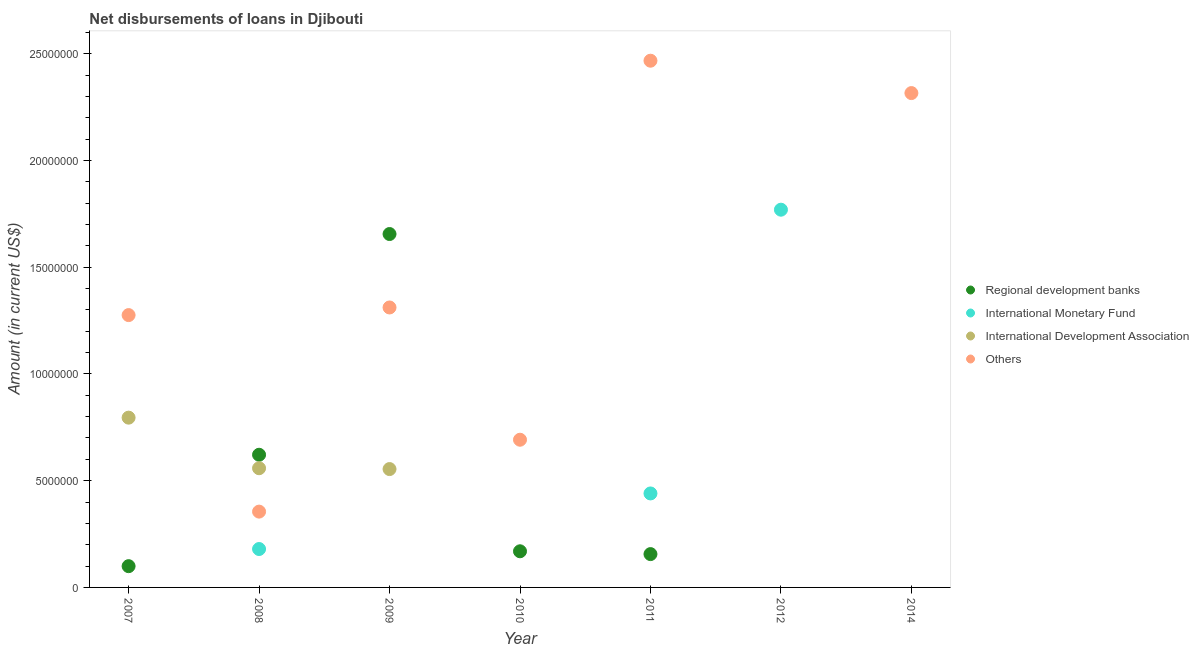How many different coloured dotlines are there?
Offer a very short reply. 4. Across all years, what is the maximum amount of loan disimbursed by other organisations?
Your response must be concise. 2.47e+07. In which year was the amount of loan disimbursed by international monetary fund maximum?
Make the answer very short. 2012. What is the total amount of loan disimbursed by international development association in the graph?
Ensure brevity in your answer.  1.91e+07. What is the difference between the amount of loan disimbursed by other organisations in 2007 and that in 2008?
Offer a very short reply. 9.20e+06. What is the difference between the amount of loan disimbursed by international development association in 2010 and the amount of loan disimbursed by regional development banks in 2012?
Provide a short and direct response. 0. What is the average amount of loan disimbursed by international development association per year?
Provide a short and direct response. 2.73e+06. In the year 2008, what is the difference between the amount of loan disimbursed by regional development banks and amount of loan disimbursed by other organisations?
Provide a succinct answer. 2.66e+06. What is the ratio of the amount of loan disimbursed by international development association in 2007 to that in 2009?
Your response must be concise. 1.43. What is the difference between the highest and the second highest amount of loan disimbursed by international monetary fund?
Offer a very short reply. 1.33e+07. What is the difference between the highest and the lowest amount of loan disimbursed by regional development banks?
Provide a short and direct response. 1.66e+07. In how many years, is the amount of loan disimbursed by international monetary fund greater than the average amount of loan disimbursed by international monetary fund taken over all years?
Ensure brevity in your answer.  2. Is the sum of the amount of loan disimbursed by regional development banks in 2008 and 2011 greater than the maximum amount of loan disimbursed by international development association across all years?
Offer a terse response. No. Is it the case that in every year, the sum of the amount of loan disimbursed by international monetary fund and amount of loan disimbursed by other organisations is greater than the sum of amount of loan disimbursed by international development association and amount of loan disimbursed by regional development banks?
Give a very brief answer. No. Is it the case that in every year, the sum of the amount of loan disimbursed by regional development banks and amount of loan disimbursed by international monetary fund is greater than the amount of loan disimbursed by international development association?
Your answer should be very brief. No. How many years are there in the graph?
Make the answer very short. 7. What is the difference between two consecutive major ticks on the Y-axis?
Provide a short and direct response. 5.00e+06. Are the values on the major ticks of Y-axis written in scientific E-notation?
Make the answer very short. No. Does the graph contain any zero values?
Your response must be concise. Yes. How are the legend labels stacked?
Give a very brief answer. Vertical. What is the title of the graph?
Ensure brevity in your answer.  Net disbursements of loans in Djibouti. Does "Energy" appear as one of the legend labels in the graph?
Provide a succinct answer. No. What is the Amount (in current US$) of Regional development banks in 2007?
Keep it short and to the point. 9.96e+05. What is the Amount (in current US$) in International Development Association in 2007?
Provide a succinct answer. 7.95e+06. What is the Amount (in current US$) of Others in 2007?
Provide a succinct answer. 1.28e+07. What is the Amount (in current US$) in Regional development banks in 2008?
Offer a terse response. 6.21e+06. What is the Amount (in current US$) in International Monetary Fund in 2008?
Provide a succinct answer. 1.80e+06. What is the Amount (in current US$) in International Development Association in 2008?
Give a very brief answer. 5.58e+06. What is the Amount (in current US$) in Others in 2008?
Your answer should be compact. 3.55e+06. What is the Amount (in current US$) in Regional development banks in 2009?
Your answer should be compact. 1.66e+07. What is the Amount (in current US$) in International Monetary Fund in 2009?
Ensure brevity in your answer.  0. What is the Amount (in current US$) in International Development Association in 2009?
Ensure brevity in your answer.  5.54e+06. What is the Amount (in current US$) of Others in 2009?
Keep it short and to the point. 1.31e+07. What is the Amount (in current US$) of Regional development banks in 2010?
Ensure brevity in your answer.  1.69e+06. What is the Amount (in current US$) in International Development Association in 2010?
Your response must be concise. 0. What is the Amount (in current US$) of Others in 2010?
Your answer should be compact. 6.92e+06. What is the Amount (in current US$) in Regional development banks in 2011?
Give a very brief answer. 1.56e+06. What is the Amount (in current US$) in International Monetary Fund in 2011?
Provide a short and direct response. 4.40e+06. What is the Amount (in current US$) of Others in 2011?
Ensure brevity in your answer.  2.47e+07. What is the Amount (in current US$) of International Monetary Fund in 2012?
Your answer should be compact. 1.77e+07. What is the Amount (in current US$) of International Development Association in 2012?
Offer a very short reply. 0. What is the Amount (in current US$) in Others in 2012?
Offer a terse response. 0. What is the Amount (in current US$) of Regional development banks in 2014?
Provide a short and direct response. 0. What is the Amount (in current US$) in Others in 2014?
Make the answer very short. 2.32e+07. Across all years, what is the maximum Amount (in current US$) of Regional development banks?
Provide a short and direct response. 1.66e+07. Across all years, what is the maximum Amount (in current US$) in International Monetary Fund?
Give a very brief answer. 1.77e+07. Across all years, what is the maximum Amount (in current US$) of International Development Association?
Provide a succinct answer. 7.95e+06. Across all years, what is the maximum Amount (in current US$) in Others?
Ensure brevity in your answer.  2.47e+07. Across all years, what is the minimum Amount (in current US$) of International Monetary Fund?
Your response must be concise. 0. Across all years, what is the minimum Amount (in current US$) in International Development Association?
Offer a terse response. 0. What is the total Amount (in current US$) in Regional development banks in the graph?
Ensure brevity in your answer.  2.70e+07. What is the total Amount (in current US$) in International Monetary Fund in the graph?
Give a very brief answer. 2.39e+07. What is the total Amount (in current US$) in International Development Association in the graph?
Your response must be concise. 1.91e+07. What is the total Amount (in current US$) in Others in the graph?
Your answer should be compact. 8.42e+07. What is the difference between the Amount (in current US$) of Regional development banks in 2007 and that in 2008?
Your answer should be very brief. -5.22e+06. What is the difference between the Amount (in current US$) in International Development Association in 2007 and that in 2008?
Keep it short and to the point. 2.37e+06. What is the difference between the Amount (in current US$) of Others in 2007 and that in 2008?
Your answer should be very brief. 9.20e+06. What is the difference between the Amount (in current US$) in Regional development banks in 2007 and that in 2009?
Ensure brevity in your answer.  -1.56e+07. What is the difference between the Amount (in current US$) of International Development Association in 2007 and that in 2009?
Provide a short and direct response. 2.41e+06. What is the difference between the Amount (in current US$) in Others in 2007 and that in 2009?
Your answer should be very brief. -3.57e+05. What is the difference between the Amount (in current US$) of Regional development banks in 2007 and that in 2010?
Provide a short and direct response. -6.97e+05. What is the difference between the Amount (in current US$) of Others in 2007 and that in 2010?
Your response must be concise. 5.84e+06. What is the difference between the Amount (in current US$) in Regional development banks in 2007 and that in 2011?
Offer a terse response. -5.65e+05. What is the difference between the Amount (in current US$) in Others in 2007 and that in 2011?
Keep it short and to the point. -1.19e+07. What is the difference between the Amount (in current US$) of Others in 2007 and that in 2014?
Your answer should be compact. -1.04e+07. What is the difference between the Amount (in current US$) of Regional development banks in 2008 and that in 2009?
Provide a short and direct response. -1.03e+07. What is the difference between the Amount (in current US$) of International Development Association in 2008 and that in 2009?
Ensure brevity in your answer.  3.90e+04. What is the difference between the Amount (in current US$) in Others in 2008 and that in 2009?
Ensure brevity in your answer.  -9.56e+06. What is the difference between the Amount (in current US$) of Regional development banks in 2008 and that in 2010?
Your answer should be very brief. 4.52e+06. What is the difference between the Amount (in current US$) in Others in 2008 and that in 2010?
Offer a terse response. -3.37e+06. What is the difference between the Amount (in current US$) of Regional development banks in 2008 and that in 2011?
Give a very brief answer. 4.65e+06. What is the difference between the Amount (in current US$) in International Monetary Fund in 2008 and that in 2011?
Offer a very short reply. -2.60e+06. What is the difference between the Amount (in current US$) in Others in 2008 and that in 2011?
Your answer should be compact. -2.11e+07. What is the difference between the Amount (in current US$) in International Monetary Fund in 2008 and that in 2012?
Keep it short and to the point. -1.59e+07. What is the difference between the Amount (in current US$) in Others in 2008 and that in 2014?
Provide a short and direct response. -1.96e+07. What is the difference between the Amount (in current US$) in Regional development banks in 2009 and that in 2010?
Give a very brief answer. 1.49e+07. What is the difference between the Amount (in current US$) in Others in 2009 and that in 2010?
Provide a short and direct response. 6.20e+06. What is the difference between the Amount (in current US$) of Regional development banks in 2009 and that in 2011?
Give a very brief answer. 1.50e+07. What is the difference between the Amount (in current US$) of Others in 2009 and that in 2011?
Offer a very short reply. -1.16e+07. What is the difference between the Amount (in current US$) of Others in 2009 and that in 2014?
Provide a short and direct response. -1.00e+07. What is the difference between the Amount (in current US$) in Regional development banks in 2010 and that in 2011?
Your answer should be compact. 1.32e+05. What is the difference between the Amount (in current US$) of Others in 2010 and that in 2011?
Keep it short and to the point. -1.78e+07. What is the difference between the Amount (in current US$) in Others in 2010 and that in 2014?
Your answer should be compact. -1.62e+07. What is the difference between the Amount (in current US$) of International Monetary Fund in 2011 and that in 2012?
Provide a short and direct response. -1.33e+07. What is the difference between the Amount (in current US$) of Others in 2011 and that in 2014?
Ensure brevity in your answer.  1.52e+06. What is the difference between the Amount (in current US$) in Regional development banks in 2007 and the Amount (in current US$) in International Monetary Fund in 2008?
Keep it short and to the point. -8.03e+05. What is the difference between the Amount (in current US$) in Regional development banks in 2007 and the Amount (in current US$) in International Development Association in 2008?
Make the answer very short. -4.59e+06. What is the difference between the Amount (in current US$) of Regional development banks in 2007 and the Amount (in current US$) of Others in 2008?
Ensure brevity in your answer.  -2.56e+06. What is the difference between the Amount (in current US$) of International Development Association in 2007 and the Amount (in current US$) of Others in 2008?
Your response must be concise. 4.40e+06. What is the difference between the Amount (in current US$) of Regional development banks in 2007 and the Amount (in current US$) of International Development Association in 2009?
Offer a terse response. -4.55e+06. What is the difference between the Amount (in current US$) of Regional development banks in 2007 and the Amount (in current US$) of Others in 2009?
Offer a terse response. -1.21e+07. What is the difference between the Amount (in current US$) of International Development Association in 2007 and the Amount (in current US$) of Others in 2009?
Keep it short and to the point. -5.16e+06. What is the difference between the Amount (in current US$) in Regional development banks in 2007 and the Amount (in current US$) in Others in 2010?
Ensure brevity in your answer.  -5.92e+06. What is the difference between the Amount (in current US$) in International Development Association in 2007 and the Amount (in current US$) in Others in 2010?
Ensure brevity in your answer.  1.03e+06. What is the difference between the Amount (in current US$) of Regional development banks in 2007 and the Amount (in current US$) of International Monetary Fund in 2011?
Offer a very short reply. -3.41e+06. What is the difference between the Amount (in current US$) in Regional development banks in 2007 and the Amount (in current US$) in Others in 2011?
Provide a short and direct response. -2.37e+07. What is the difference between the Amount (in current US$) in International Development Association in 2007 and the Amount (in current US$) in Others in 2011?
Give a very brief answer. -1.67e+07. What is the difference between the Amount (in current US$) in Regional development banks in 2007 and the Amount (in current US$) in International Monetary Fund in 2012?
Give a very brief answer. -1.67e+07. What is the difference between the Amount (in current US$) of Regional development banks in 2007 and the Amount (in current US$) of Others in 2014?
Make the answer very short. -2.22e+07. What is the difference between the Amount (in current US$) of International Development Association in 2007 and the Amount (in current US$) of Others in 2014?
Offer a terse response. -1.52e+07. What is the difference between the Amount (in current US$) in Regional development banks in 2008 and the Amount (in current US$) in International Development Association in 2009?
Provide a short and direct response. 6.70e+05. What is the difference between the Amount (in current US$) in Regional development banks in 2008 and the Amount (in current US$) in Others in 2009?
Keep it short and to the point. -6.90e+06. What is the difference between the Amount (in current US$) in International Monetary Fund in 2008 and the Amount (in current US$) in International Development Association in 2009?
Provide a short and direct response. -3.74e+06. What is the difference between the Amount (in current US$) of International Monetary Fund in 2008 and the Amount (in current US$) of Others in 2009?
Keep it short and to the point. -1.13e+07. What is the difference between the Amount (in current US$) in International Development Association in 2008 and the Amount (in current US$) in Others in 2009?
Offer a terse response. -7.53e+06. What is the difference between the Amount (in current US$) of Regional development banks in 2008 and the Amount (in current US$) of Others in 2010?
Keep it short and to the point. -7.04e+05. What is the difference between the Amount (in current US$) of International Monetary Fund in 2008 and the Amount (in current US$) of Others in 2010?
Keep it short and to the point. -5.12e+06. What is the difference between the Amount (in current US$) of International Development Association in 2008 and the Amount (in current US$) of Others in 2010?
Your response must be concise. -1.34e+06. What is the difference between the Amount (in current US$) of Regional development banks in 2008 and the Amount (in current US$) of International Monetary Fund in 2011?
Make the answer very short. 1.81e+06. What is the difference between the Amount (in current US$) of Regional development banks in 2008 and the Amount (in current US$) of Others in 2011?
Your answer should be very brief. -1.85e+07. What is the difference between the Amount (in current US$) of International Monetary Fund in 2008 and the Amount (in current US$) of Others in 2011?
Make the answer very short. -2.29e+07. What is the difference between the Amount (in current US$) in International Development Association in 2008 and the Amount (in current US$) in Others in 2011?
Give a very brief answer. -1.91e+07. What is the difference between the Amount (in current US$) in Regional development banks in 2008 and the Amount (in current US$) in International Monetary Fund in 2012?
Offer a very short reply. -1.15e+07. What is the difference between the Amount (in current US$) of Regional development banks in 2008 and the Amount (in current US$) of Others in 2014?
Make the answer very short. -1.69e+07. What is the difference between the Amount (in current US$) in International Monetary Fund in 2008 and the Amount (in current US$) in Others in 2014?
Provide a succinct answer. -2.14e+07. What is the difference between the Amount (in current US$) of International Development Association in 2008 and the Amount (in current US$) of Others in 2014?
Offer a terse response. -1.76e+07. What is the difference between the Amount (in current US$) of Regional development banks in 2009 and the Amount (in current US$) of Others in 2010?
Ensure brevity in your answer.  9.64e+06. What is the difference between the Amount (in current US$) of International Development Association in 2009 and the Amount (in current US$) of Others in 2010?
Your response must be concise. -1.37e+06. What is the difference between the Amount (in current US$) in Regional development banks in 2009 and the Amount (in current US$) in International Monetary Fund in 2011?
Keep it short and to the point. 1.22e+07. What is the difference between the Amount (in current US$) in Regional development banks in 2009 and the Amount (in current US$) in Others in 2011?
Give a very brief answer. -8.12e+06. What is the difference between the Amount (in current US$) of International Development Association in 2009 and the Amount (in current US$) of Others in 2011?
Keep it short and to the point. -1.91e+07. What is the difference between the Amount (in current US$) in Regional development banks in 2009 and the Amount (in current US$) in International Monetary Fund in 2012?
Keep it short and to the point. -1.14e+06. What is the difference between the Amount (in current US$) of Regional development banks in 2009 and the Amount (in current US$) of Others in 2014?
Keep it short and to the point. -6.60e+06. What is the difference between the Amount (in current US$) in International Development Association in 2009 and the Amount (in current US$) in Others in 2014?
Your answer should be compact. -1.76e+07. What is the difference between the Amount (in current US$) in Regional development banks in 2010 and the Amount (in current US$) in International Monetary Fund in 2011?
Your answer should be compact. -2.71e+06. What is the difference between the Amount (in current US$) in Regional development banks in 2010 and the Amount (in current US$) in Others in 2011?
Provide a succinct answer. -2.30e+07. What is the difference between the Amount (in current US$) of Regional development banks in 2010 and the Amount (in current US$) of International Monetary Fund in 2012?
Offer a terse response. -1.60e+07. What is the difference between the Amount (in current US$) of Regional development banks in 2010 and the Amount (in current US$) of Others in 2014?
Provide a succinct answer. -2.15e+07. What is the difference between the Amount (in current US$) in Regional development banks in 2011 and the Amount (in current US$) in International Monetary Fund in 2012?
Offer a very short reply. -1.61e+07. What is the difference between the Amount (in current US$) of Regional development banks in 2011 and the Amount (in current US$) of Others in 2014?
Provide a short and direct response. -2.16e+07. What is the difference between the Amount (in current US$) of International Monetary Fund in 2011 and the Amount (in current US$) of Others in 2014?
Your response must be concise. -1.88e+07. What is the difference between the Amount (in current US$) in International Monetary Fund in 2012 and the Amount (in current US$) in Others in 2014?
Offer a very short reply. -5.46e+06. What is the average Amount (in current US$) in Regional development banks per year?
Provide a succinct answer. 3.86e+06. What is the average Amount (in current US$) in International Monetary Fund per year?
Your answer should be compact. 3.41e+06. What is the average Amount (in current US$) of International Development Association per year?
Your answer should be very brief. 2.73e+06. What is the average Amount (in current US$) of Others per year?
Your answer should be compact. 1.20e+07. In the year 2007, what is the difference between the Amount (in current US$) in Regional development banks and Amount (in current US$) in International Development Association?
Keep it short and to the point. -6.96e+06. In the year 2007, what is the difference between the Amount (in current US$) of Regional development banks and Amount (in current US$) of Others?
Offer a very short reply. -1.18e+07. In the year 2007, what is the difference between the Amount (in current US$) of International Development Association and Amount (in current US$) of Others?
Give a very brief answer. -4.80e+06. In the year 2008, what is the difference between the Amount (in current US$) in Regional development banks and Amount (in current US$) in International Monetary Fund?
Offer a very short reply. 4.42e+06. In the year 2008, what is the difference between the Amount (in current US$) of Regional development banks and Amount (in current US$) of International Development Association?
Offer a very short reply. 6.31e+05. In the year 2008, what is the difference between the Amount (in current US$) of Regional development banks and Amount (in current US$) of Others?
Your response must be concise. 2.66e+06. In the year 2008, what is the difference between the Amount (in current US$) of International Monetary Fund and Amount (in current US$) of International Development Association?
Give a very brief answer. -3.78e+06. In the year 2008, what is the difference between the Amount (in current US$) of International Monetary Fund and Amount (in current US$) of Others?
Provide a short and direct response. -1.75e+06. In the year 2008, what is the difference between the Amount (in current US$) in International Development Association and Amount (in current US$) in Others?
Provide a succinct answer. 2.03e+06. In the year 2009, what is the difference between the Amount (in current US$) in Regional development banks and Amount (in current US$) in International Development Association?
Keep it short and to the point. 1.10e+07. In the year 2009, what is the difference between the Amount (in current US$) of Regional development banks and Amount (in current US$) of Others?
Your response must be concise. 3.44e+06. In the year 2009, what is the difference between the Amount (in current US$) of International Development Association and Amount (in current US$) of Others?
Your answer should be very brief. -7.57e+06. In the year 2010, what is the difference between the Amount (in current US$) in Regional development banks and Amount (in current US$) in Others?
Offer a very short reply. -5.22e+06. In the year 2011, what is the difference between the Amount (in current US$) of Regional development banks and Amount (in current US$) of International Monetary Fund?
Offer a very short reply. -2.84e+06. In the year 2011, what is the difference between the Amount (in current US$) of Regional development banks and Amount (in current US$) of Others?
Make the answer very short. -2.31e+07. In the year 2011, what is the difference between the Amount (in current US$) of International Monetary Fund and Amount (in current US$) of Others?
Provide a succinct answer. -2.03e+07. What is the ratio of the Amount (in current US$) in Regional development banks in 2007 to that in 2008?
Your answer should be compact. 0.16. What is the ratio of the Amount (in current US$) of International Development Association in 2007 to that in 2008?
Offer a very short reply. 1.42. What is the ratio of the Amount (in current US$) in Others in 2007 to that in 2008?
Provide a succinct answer. 3.59. What is the ratio of the Amount (in current US$) in Regional development banks in 2007 to that in 2009?
Your response must be concise. 0.06. What is the ratio of the Amount (in current US$) of International Development Association in 2007 to that in 2009?
Provide a succinct answer. 1.43. What is the ratio of the Amount (in current US$) in Others in 2007 to that in 2009?
Keep it short and to the point. 0.97. What is the ratio of the Amount (in current US$) of Regional development banks in 2007 to that in 2010?
Offer a very short reply. 0.59. What is the ratio of the Amount (in current US$) in Others in 2007 to that in 2010?
Keep it short and to the point. 1.84. What is the ratio of the Amount (in current US$) in Regional development banks in 2007 to that in 2011?
Give a very brief answer. 0.64. What is the ratio of the Amount (in current US$) in Others in 2007 to that in 2011?
Give a very brief answer. 0.52. What is the ratio of the Amount (in current US$) in Others in 2007 to that in 2014?
Your answer should be compact. 0.55. What is the ratio of the Amount (in current US$) in Regional development banks in 2008 to that in 2009?
Your response must be concise. 0.38. What is the ratio of the Amount (in current US$) of International Development Association in 2008 to that in 2009?
Your answer should be compact. 1.01. What is the ratio of the Amount (in current US$) in Others in 2008 to that in 2009?
Keep it short and to the point. 0.27. What is the ratio of the Amount (in current US$) of Regional development banks in 2008 to that in 2010?
Keep it short and to the point. 3.67. What is the ratio of the Amount (in current US$) of Others in 2008 to that in 2010?
Keep it short and to the point. 0.51. What is the ratio of the Amount (in current US$) in Regional development banks in 2008 to that in 2011?
Offer a terse response. 3.98. What is the ratio of the Amount (in current US$) in International Monetary Fund in 2008 to that in 2011?
Provide a succinct answer. 0.41. What is the ratio of the Amount (in current US$) in Others in 2008 to that in 2011?
Offer a terse response. 0.14. What is the ratio of the Amount (in current US$) in International Monetary Fund in 2008 to that in 2012?
Your response must be concise. 0.1. What is the ratio of the Amount (in current US$) in Others in 2008 to that in 2014?
Offer a terse response. 0.15. What is the ratio of the Amount (in current US$) of Regional development banks in 2009 to that in 2010?
Your answer should be very brief. 9.78. What is the ratio of the Amount (in current US$) in Others in 2009 to that in 2010?
Your response must be concise. 1.9. What is the ratio of the Amount (in current US$) in Regional development banks in 2009 to that in 2011?
Your response must be concise. 10.6. What is the ratio of the Amount (in current US$) of Others in 2009 to that in 2011?
Ensure brevity in your answer.  0.53. What is the ratio of the Amount (in current US$) in Others in 2009 to that in 2014?
Make the answer very short. 0.57. What is the ratio of the Amount (in current US$) of Regional development banks in 2010 to that in 2011?
Your response must be concise. 1.08. What is the ratio of the Amount (in current US$) in Others in 2010 to that in 2011?
Provide a succinct answer. 0.28. What is the ratio of the Amount (in current US$) of Others in 2010 to that in 2014?
Your answer should be very brief. 0.3. What is the ratio of the Amount (in current US$) of International Monetary Fund in 2011 to that in 2012?
Provide a short and direct response. 0.25. What is the ratio of the Amount (in current US$) in Others in 2011 to that in 2014?
Give a very brief answer. 1.07. What is the difference between the highest and the second highest Amount (in current US$) of Regional development banks?
Your answer should be very brief. 1.03e+07. What is the difference between the highest and the second highest Amount (in current US$) of International Monetary Fund?
Provide a succinct answer. 1.33e+07. What is the difference between the highest and the second highest Amount (in current US$) in International Development Association?
Keep it short and to the point. 2.37e+06. What is the difference between the highest and the second highest Amount (in current US$) in Others?
Ensure brevity in your answer.  1.52e+06. What is the difference between the highest and the lowest Amount (in current US$) of Regional development banks?
Give a very brief answer. 1.66e+07. What is the difference between the highest and the lowest Amount (in current US$) in International Monetary Fund?
Make the answer very short. 1.77e+07. What is the difference between the highest and the lowest Amount (in current US$) of International Development Association?
Offer a very short reply. 7.95e+06. What is the difference between the highest and the lowest Amount (in current US$) of Others?
Give a very brief answer. 2.47e+07. 